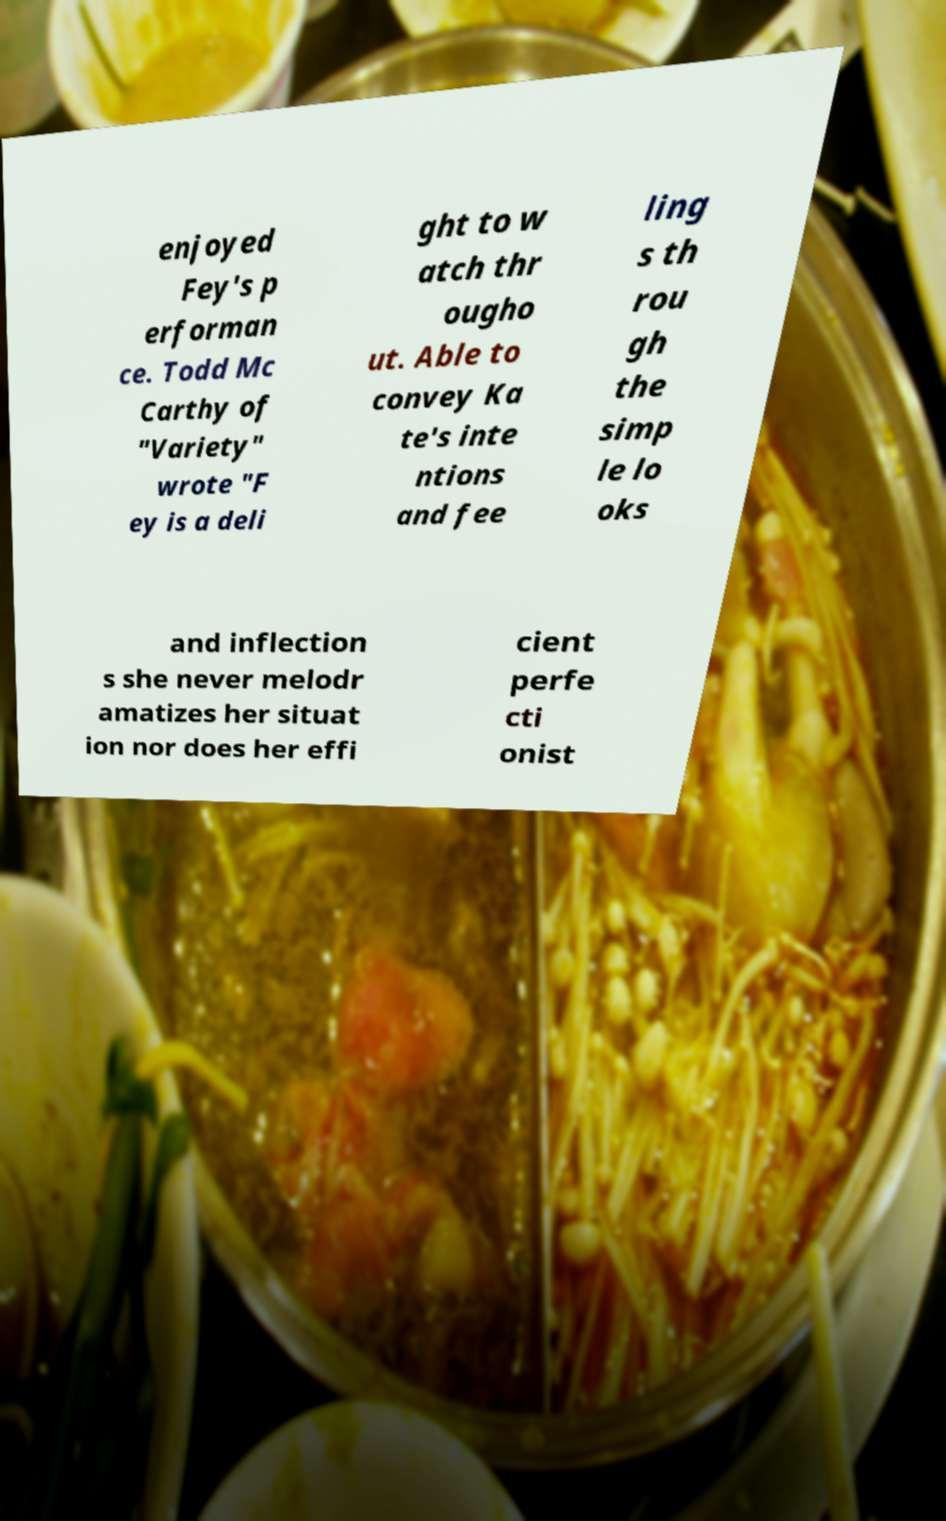Please identify and transcribe the text found in this image. enjoyed Fey's p erforman ce. Todd Mc Carthy of "Variety" wrote "F ey is a deli ght to w atch thr ougho ut. Able to convey Ka te's inte ntions and fee ling s th rou gh the simp le lo oks and inflection s she never melodr amatizes her situat ion nor does her effi cient perfe cti onist 